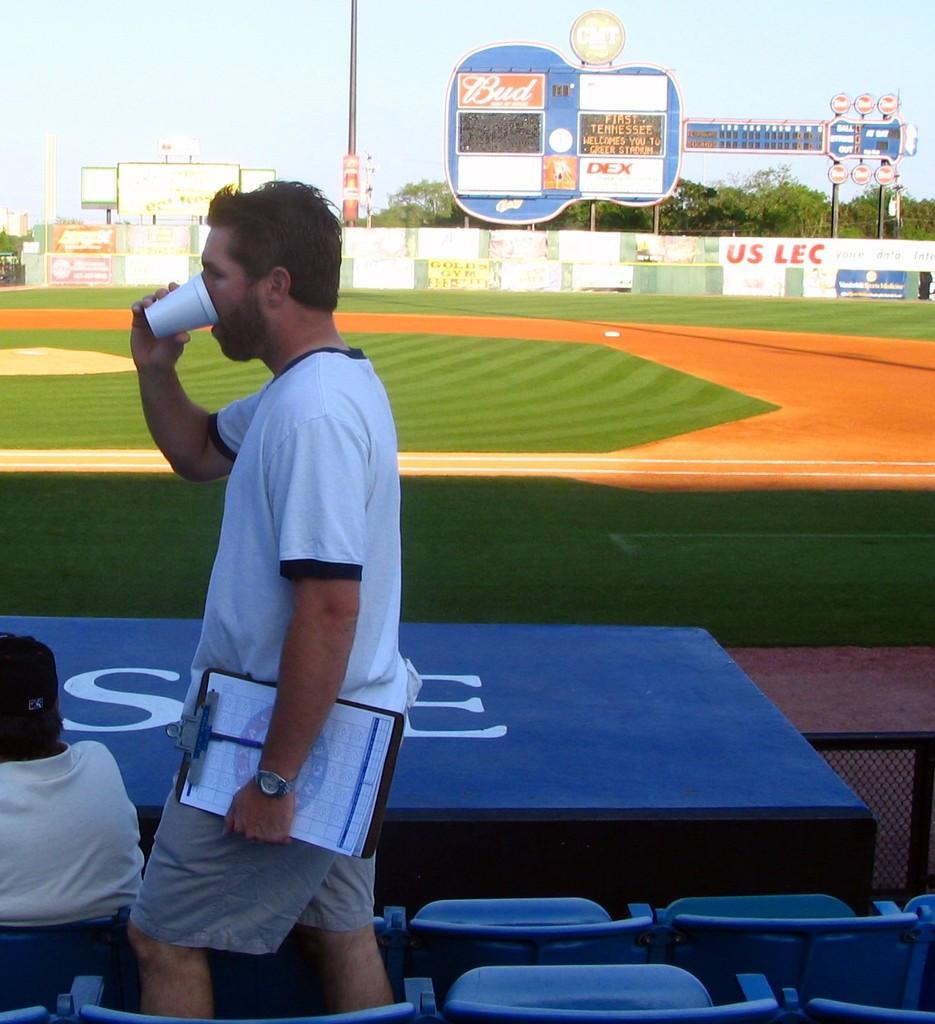<image>
Give a short and clear explanation of the subsequent image. A couple of fans at a stadium with a guitar shaped scoreboard sponsored by Budweiser. 